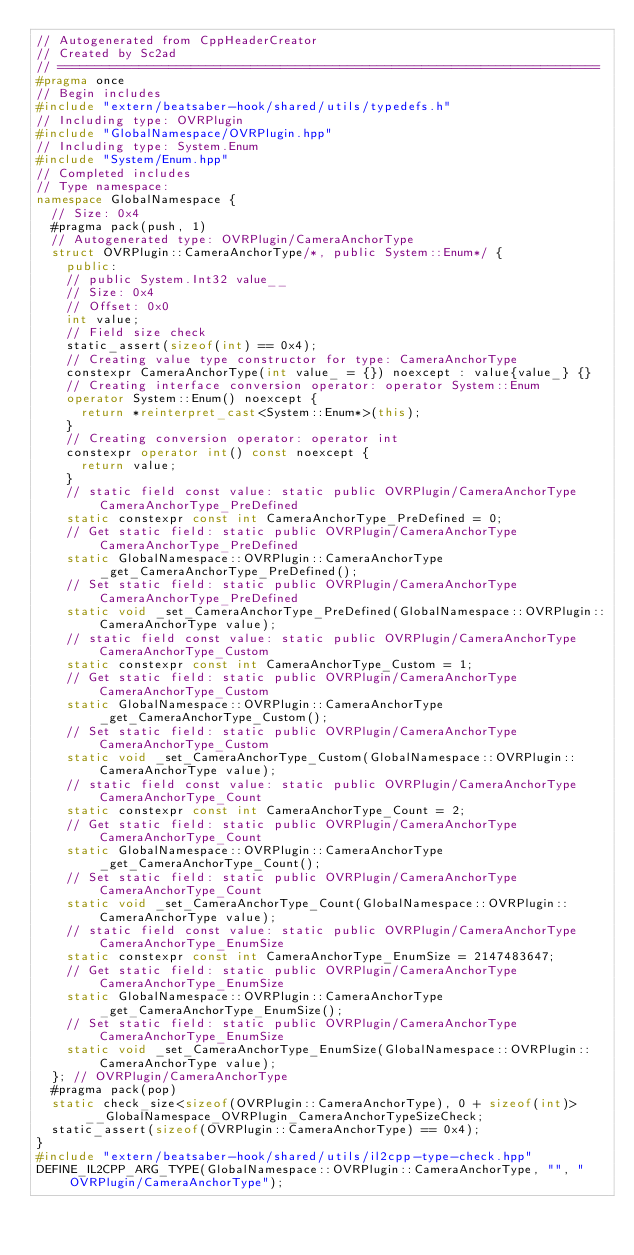Convert code to text. <code><loc_0><loc_0><loc_500><loc_500><_C++_>// Autogenerated from CppHeaderCreator
// Created by Sc2ad
// =========================================================================
#pragma once
// Begin includes
#include "extern/beatsaber-hook/shared/utils/typedefs.h"
// Including type: OVRPlugin
#include "GlobalNamespace/OVRPlugin.hpp"
// Including type: System.Enum
#include "System/Enum.hpp"
// Completed includes
// Type namespace: 
namespace GlobalNamespace {
  // Size: 0x4
  #pragma pack(push, 1)
  // Autogenerated type: OVRPlugin/CameraAnchorType
  struct OVRPlugin::CameraAnchorType/*, public System::Enum*/ {
    public:
    // public System.Int32 value__
    // Size: 0x4
    // Offset: 0x0
    int value;
    // Field size check
    static_assert(sizeof(int) == 0x4);
    // Creating value type constructor for type: CameraAnchorType
    constexpr CameraAnchorType(int value_ = {}) noexcept : value{value_} {}
    // Creating interface conversion operator: operator System::Enum
    operator System::Enum() noexcept {
      return *reinterpret_cast<System::Enum*>(this);
    }
    // Creating conversion operator: operator int
    constexpr operator int() const noexcept {
      return value;
    }
    // static field const value: static public OVRPlugin/CameraAnchorType CameraAnchorType_PreDefined
    static constexpr const int CameraAnchorType_PreDefined = 0;
    // Get static field: static public OVRPlugin/CameraAnchorType CameraAnchorType_PreDefined
    static GlobalNamespace::OVRPlugin::CameraAnchorType _get_CameraAnchorType_PreDefined();
    // Set static field: static public OVRPlugin/CameraAnchorType CameraAnchorType_PreDefined
    static void _set_CameraAnchorType_PreDefined(GlobalNamespace::OVRPlugin::CameraAnchorType value);
    // static field const value: static public OVRPlugin/CameraAnchorType CameraAnchorType_Custom
    static constexpr const int CameraAnchorType_Custom = 1;
    // Get static field: static public OVRPlugin/CameraAnchorType CameraAnchorType_Custom
    static GlobalNamespace::OVRPlugin::CameraAnchorType _get_CameraAnchorType_Custom();
    // Set static field: static public OVRPlugin/CameraAnchorType CameraAnchorType_Custom
    static void _set_CameraAnchorType_Custom(GlobalNamespace::OVRPlugin::CameraAnchorType value);
    // static field const value: static public OVRPlugin/CameraAnchorType CameraAnchorType_Count
    static constexpr const int CameraAnchorType_Count = 2;
    // Get static field: static public OVRPlugin/CameraAnchorType CameraAnchorType_Count
    static GlobalNamespace::OVRPlugin::CameraAnchorType _get_CameraAnchorType_Count();
    // Set static field: static public OVRPlugin/CameraAnchorType CameraAnchorType_Count
    static void _set_CameraAnchorType_Count(GlobalNamespace::OVRPlugin::CameraAnchorType value);
    // static field const value: static public OVRPlugin/CameraAnchorType CameraAnchorType_EnumSize
    static constexpr const int CameraAnchorType_EnumSize = 2147483647;
    // Get static field: static public OVRPlugin/CameraAnchorType CameraAnchorType_EnumSize
    static GlobalNamespace::OVRPlugin::CameraAnchorType _get_CameraAnchorType_EnumSize();
    // Set static field: static public OVRPlugin/CameraAnchorType CameraAnchorType_EnumSize
    static void _set_CameraAnchorType_EnumSize(GlobalNamespace::OVRPlugin::CameraAnchorType value);
  }; // OVRPlugin/CameraAnchorType
  #pragma pack(pop)
  static check_size<sizeof(OVRPlugin::CameraAnchorType), 0 + sizeof(int)> __GlobalNamespace_OVRPlugin_CameraAnchorTypeSizeCheck;
  static_assert(sizeof(OVRPlugin::CameraAnchorType) == 0x4);
}
#include "extern/beatsaber-hook/shared/utils/il2cpp-type-check.hpp"
DEFINE_IL2CPP_ARG_TYPE(GlobalNamespace::OVRPlugin::CameraAnchorType, "", "OVRPlugin/CameraAnchorType");
</code> 